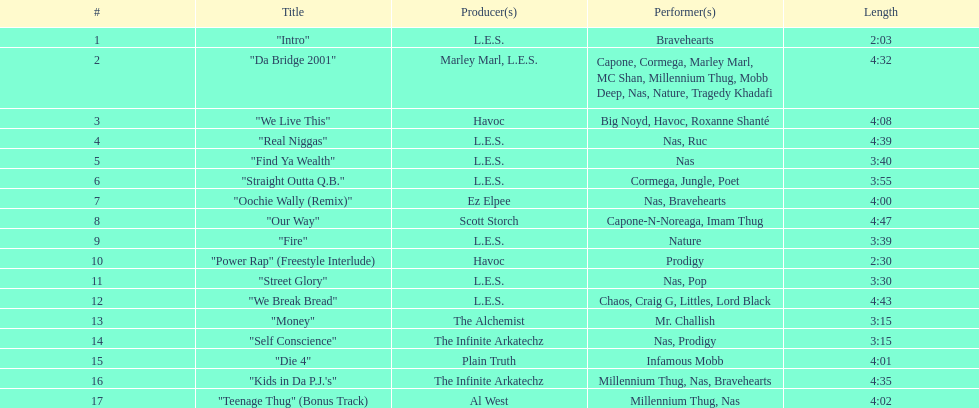What performers were in the last track? Millennium Thug, Nas. 